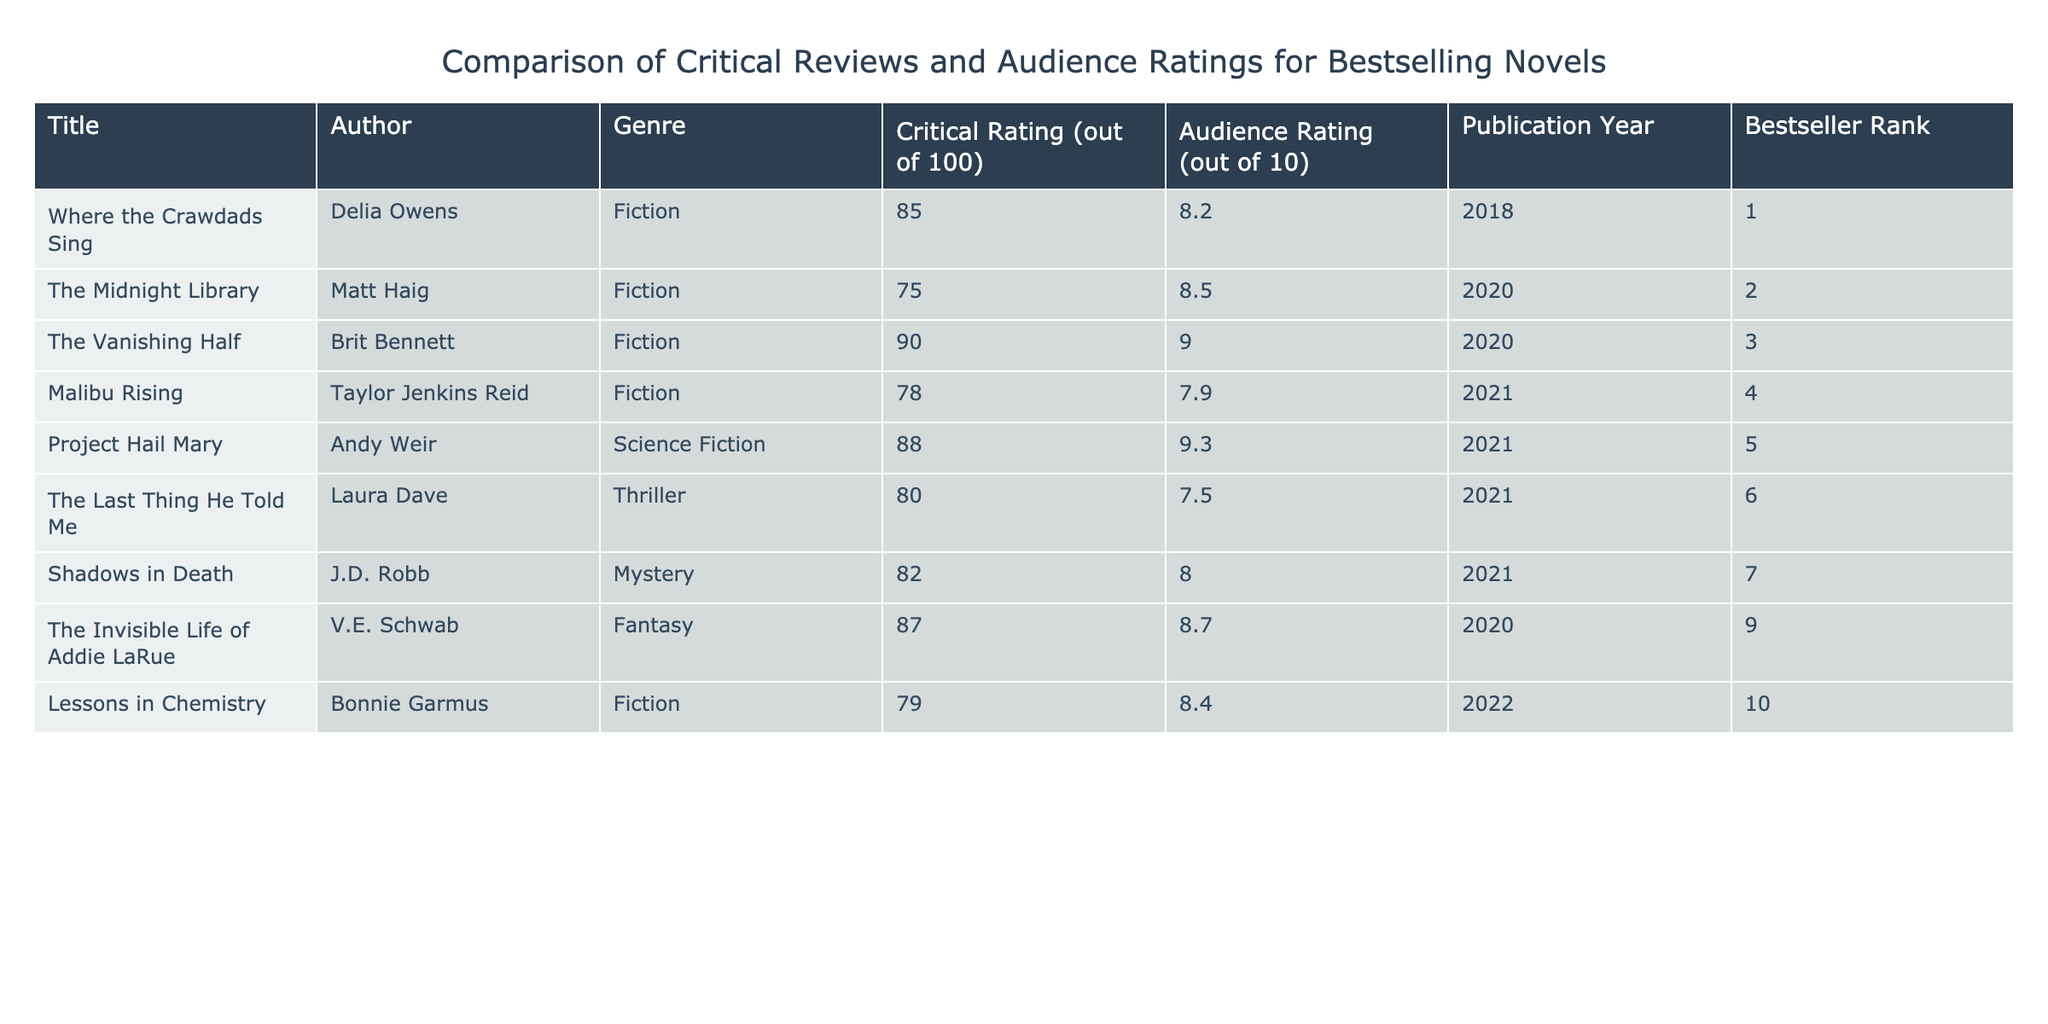What is the highest critical rating among the novels listed? To find the highest critical rating, I looked at the "Critical Rating" column in the table and identified the maximum value, which is 90 for "The Vanishing Half".
Answer: 90 Which novel has the lowest audience rating? By inspecting the "Audience Rating" column, I found that "The Last Thing He Told Me" has the lowest rating at 7.5.
Answer: 7.5 Is "Project Hail Mary" a bestseller based on the rank provided? "Project Hail Mary" is listed with a Bestseller Rank of 5, which means it is indeed a bestseller as it ranks among the top-selling novels.
Answer: Yes What is the average critical rating of the fiction novels listed? The critical ratings for fiction novels are 85, 75, 90, 78, and 79. Summing these values gives 407, and there are 5 fiction novels, so the average is 407/5 = 81.4.
Answer: 81.4 How many novels published in 2021 have an audience rating of 8 or higher? From the table, the novels published in 2021 are "Malibu Rising", "The Last Thing He Told Me", "Shadows in Death", and "Project Hail Mary". Among these, "Project Hail Mary" (9.3), and "Shadows in Death" (8.0) have ratings of 8 or higher. Therefore, there are 2 such novels.
Answer: 2 What is the difference between the highest and lowest audience ratings? The highest audience rating from the table is 9.3 (from "Project Hail Mary") and the lowest is 7.5 (from "The Last Thing He Told Me"). The difference is 9.3 - 7.5 = 1.8.
Answer: 1.8 Which genre has the novel with the highest critical rating? "The Vanishing Half", a Fiction novel, has the highest critical rating of 90 among the entries. This indicates that Fiction contains the highest-rated novel.
Answer: Fiction Did any novel published in 2020 have an audience rating lower than 8? From the 2020 publications, "The Midnight Library" has an audience rating of 8.5, and "The Invisible Life of Addie LaRue" has an audience rating of 8.7, both of which are above 8. Therefore, there are no novels from 2020 with ratings below 8.
Answer: No 